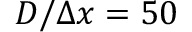Convert formula to latex. <formula><loc_0><loc_0><loc_500><loc_500>D / \Delta x = 5 0</formula> 